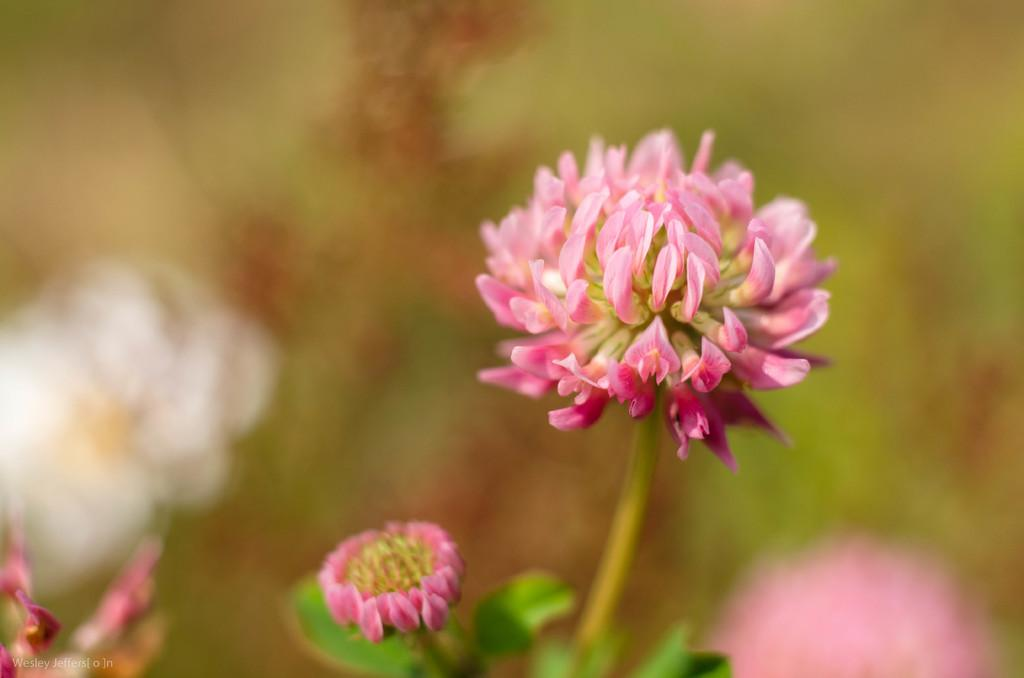What is the main subject of the image? The main subject of the image is a flower, as it is a macro photography of a flower. Can you describe any additional features or elements in the image? Yes, there is text in the bottom left corner of the image. What type of crate is visible in the image? There is no crate present in the image. What is the flower wearing on its head in the image? The flower is a natural object and does not wear any cap or headgear. 